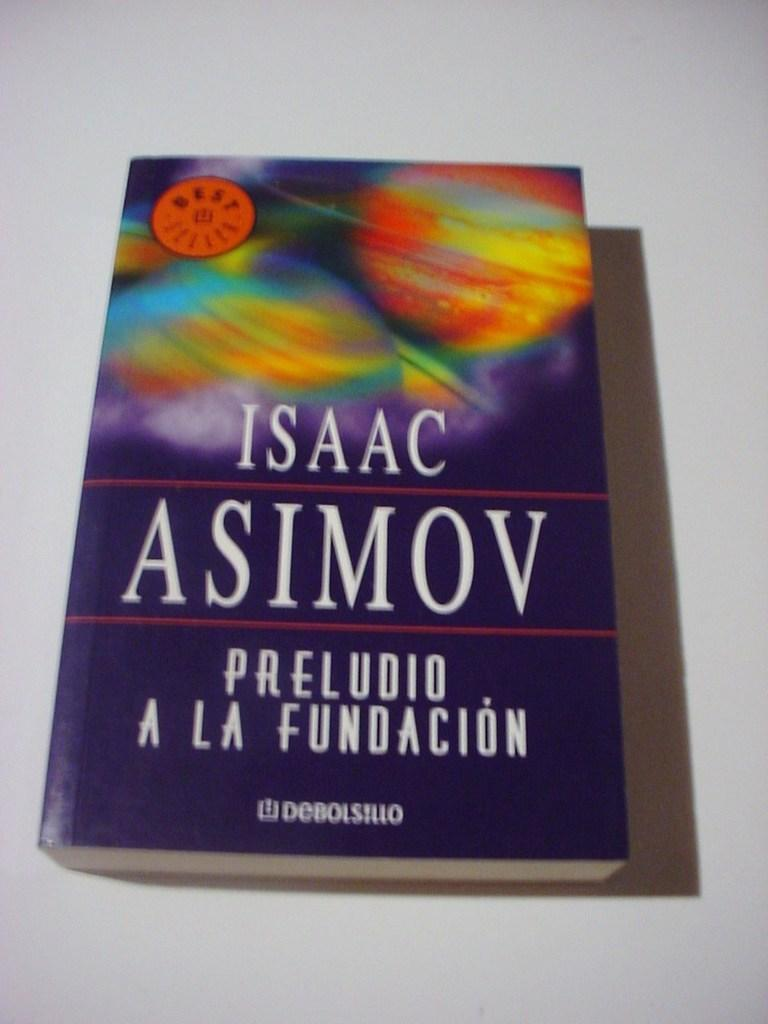<image>
Offer a succinct explanation of the picture presented. Isaac Asimov's book has a purple cover and spanish writing. 